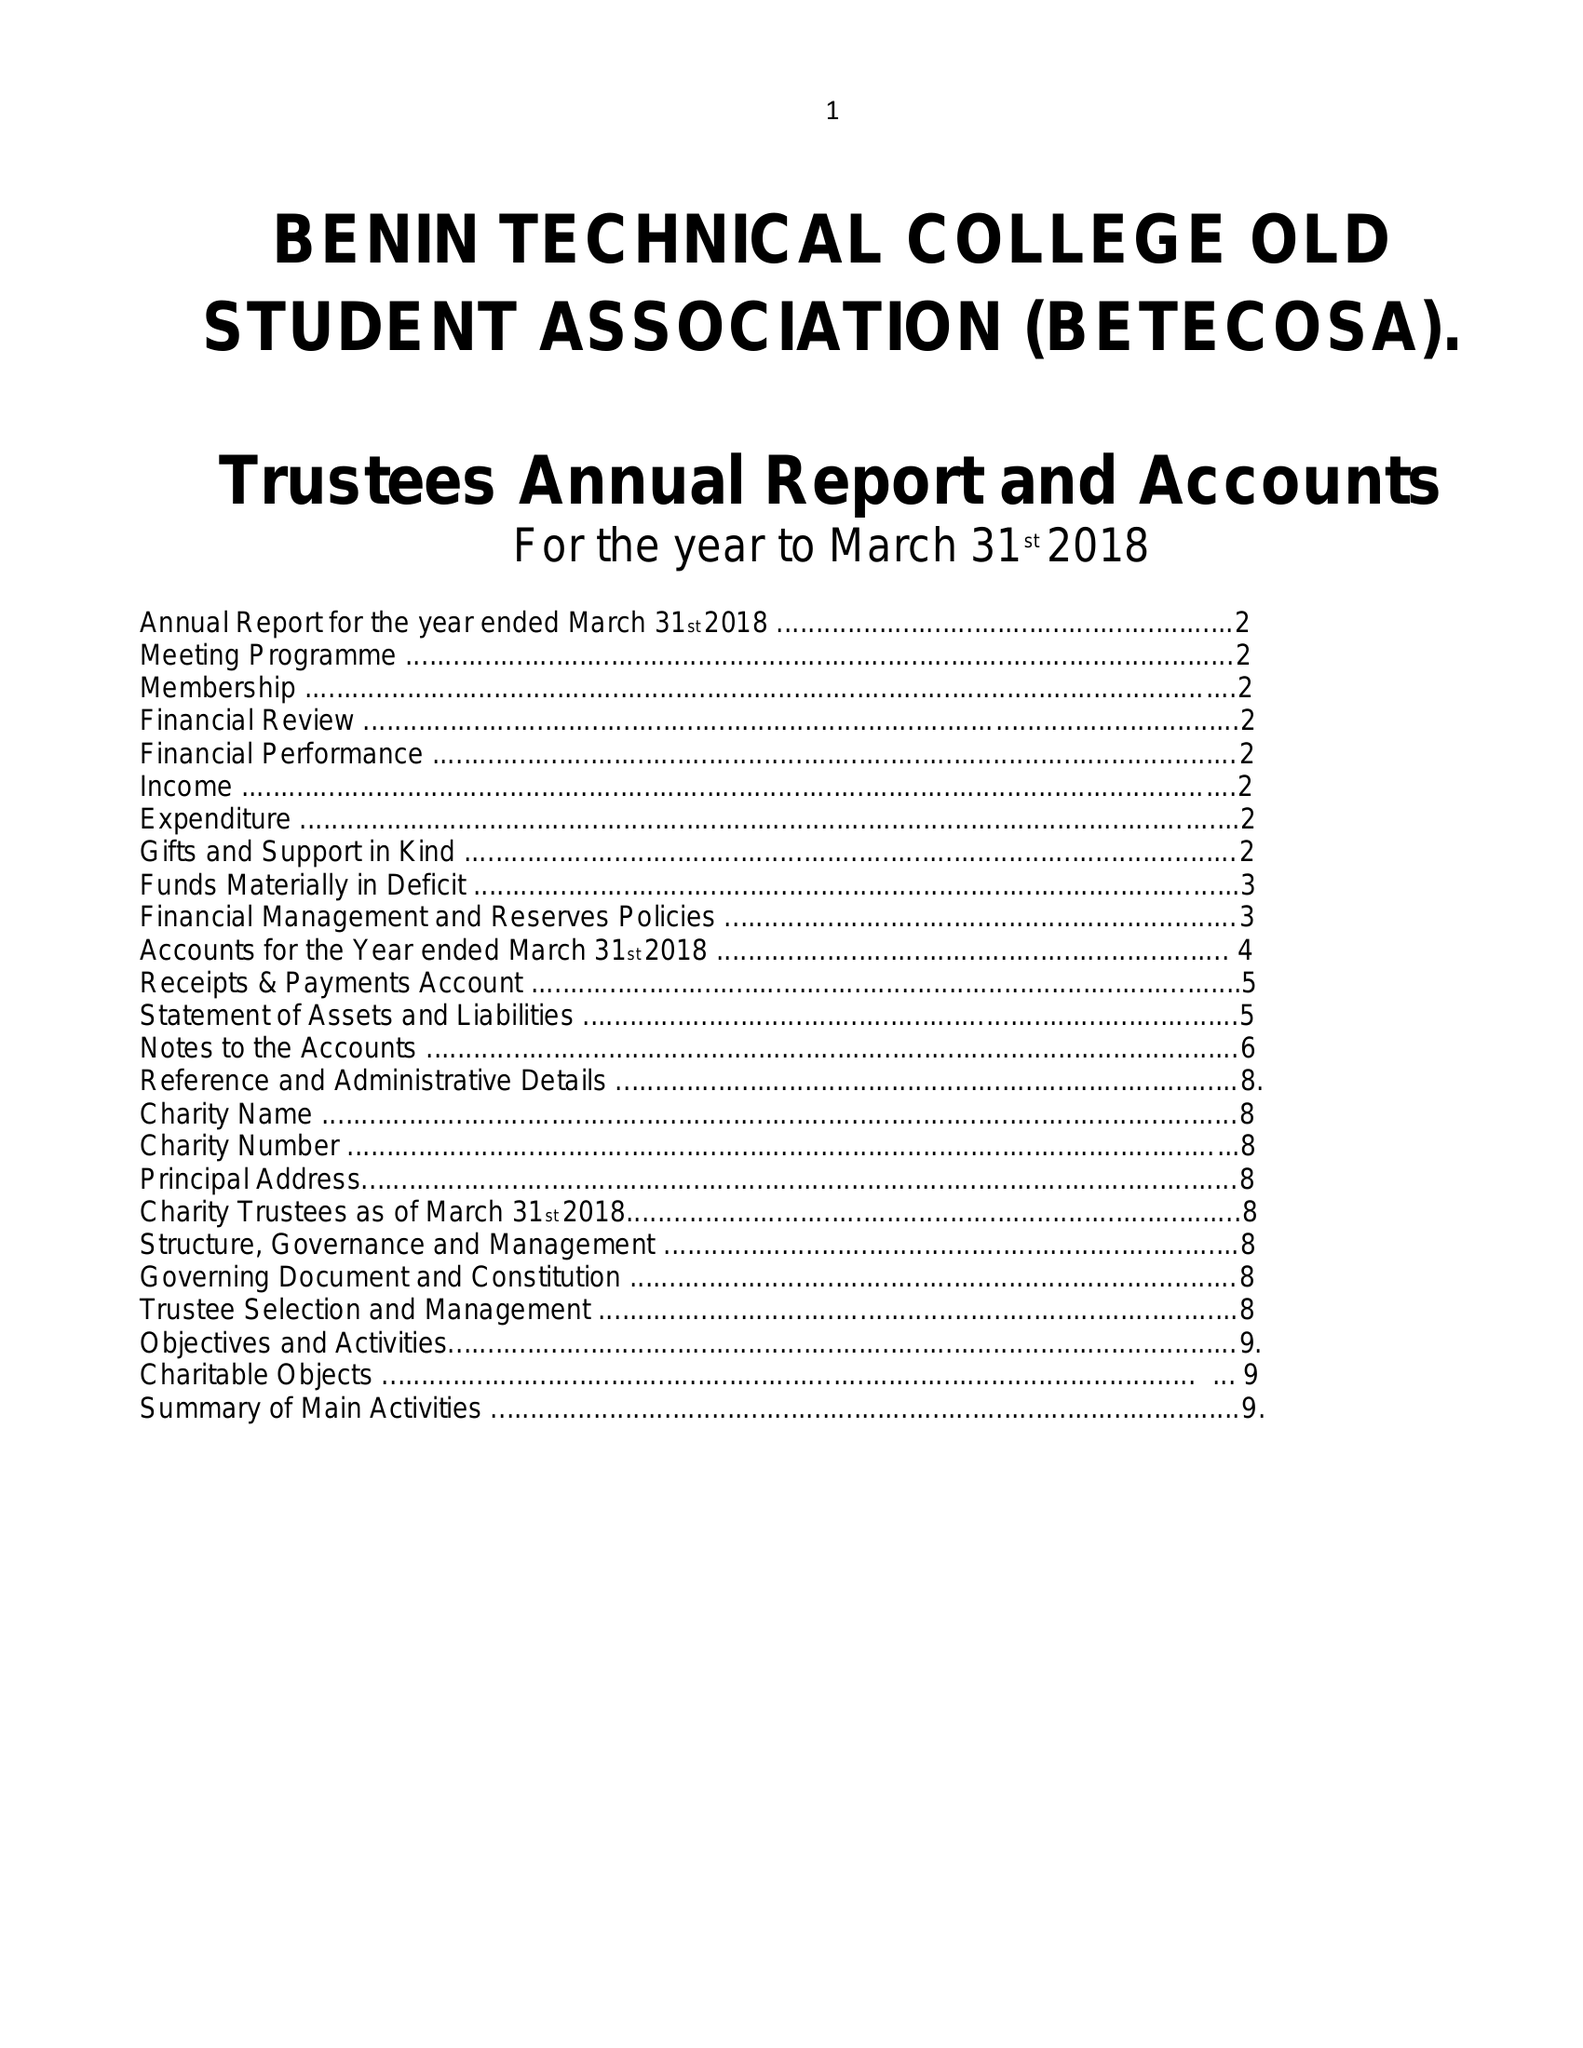What is the value for the spending_annually_in_british_pounds?
Answer the question using a single word or phrase. 14109.00 